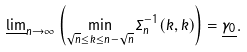Convert formula to latex. <formula><loc_0><loc_0><loc_500><loc_500>\underline { \lim } _ { n \rightarrow \infty } \left ( \min _ { \sqrt { n } \leq k \leq n - \sqrt { n } } \Sigma _ { n } ^ { - 1 } ( k , k ) \right ) = \underline { \gamma _ { 0 } } .</formula> 